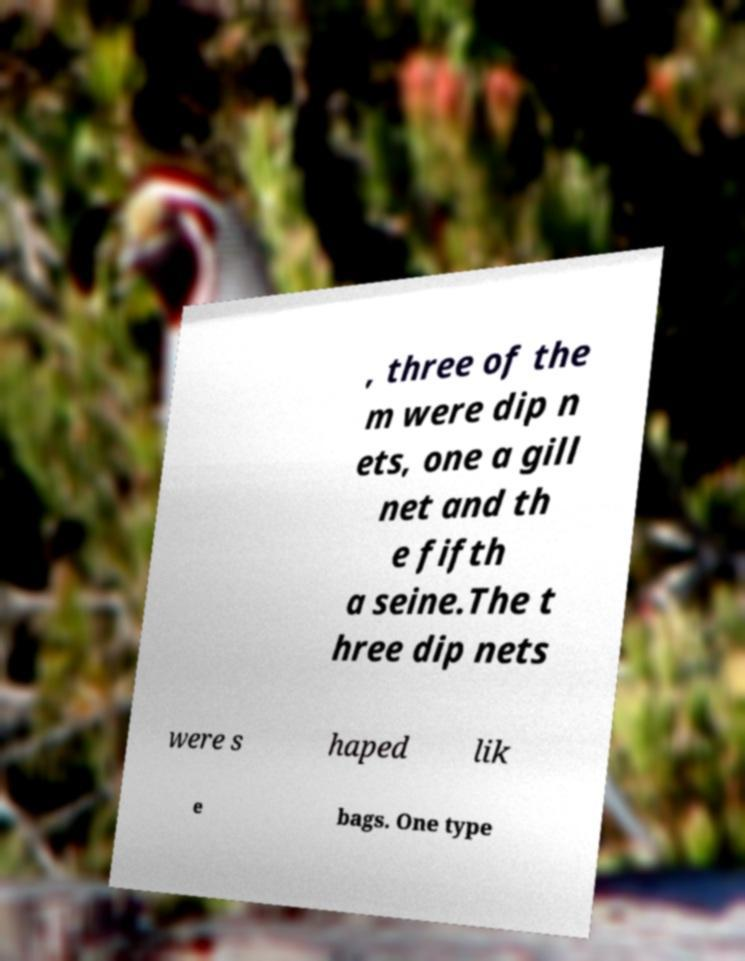What messages or text are displayed in this image? I need them in a readable, typed format. , three of the m were dip n ets, one a gill net and th e fifth a seine.The t hree dip nets were s haped lik e bags. One type 